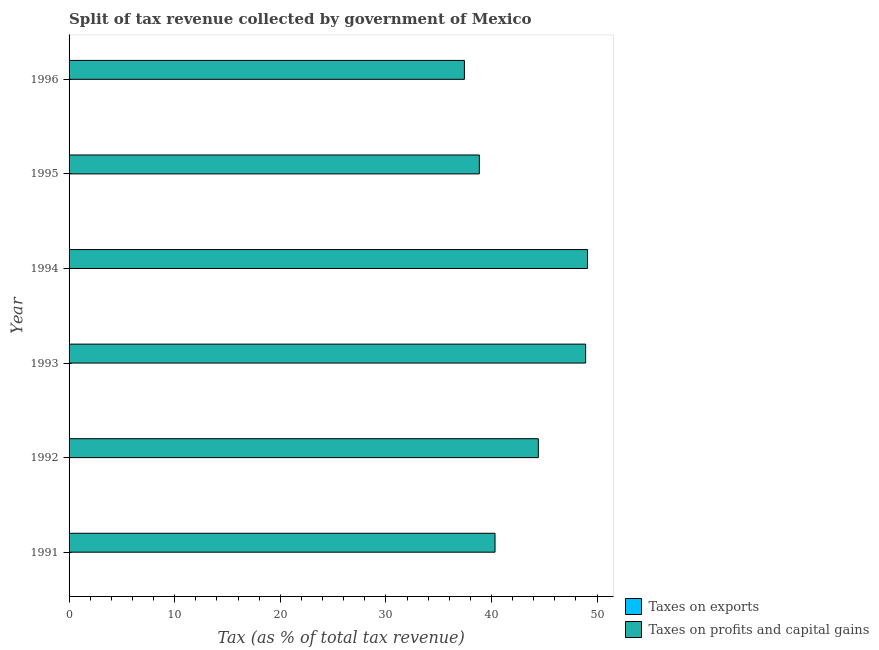Are the number of bars per tick equal to the number of legend labels?
Provide a short and direct response. Yes. In how many cases, is the number of bars for a given year not equal to the number of legend labels?
Give a very brief answer. 0. What is the percentage of revenue obtained from taxes on exports in 1993?
Your answer should be very brief. 0.02. Across all years, what is the maximum percentage of revenue obtained from taxes on exports?
Give a very brief answer. 0.04. Across all years, what is the minimum percentage of revenue obtained from taxes on exports?
Offer a very short reply. 0.02. In which year was the percentage of revenue obtained from taxes on profits and capital gains maximum?
Offer a very short reply. 1994. In which year was the percentage of revenue obtained from taxes on profits and capital gains minimum?
Your answer should be compact. 1996. What is the total percentage of revenue obtained from taxes on exports in the graph?
Ensure brevity in your answer.  0.17. What is the difference between the percentage of revenue obtained from taxes on exports in 1991 and that in 1993?
Your answer should be compact. 0.02. What is the difference between the percentage of revenue obtained from taxes on profits and capital gains in 1992 and the percentage of revenue obtained from taxes on exports in 1994?
Provide a succinct answer. 44.41. What is the average percentage of revenue obtained from taxes on exports per year?
Keep it short and to the point. 0.03. In the year 1991, what is the difference between the percentage of revenue obtained from taxes on exports and percentage of revenue obtained from taxes on profits and capital gains?
Make the answer very short. -40.3. In how many years, is the percentage of revenue obtained from taxes on profits and capital gains greater than 18 %?
Provide a succinct answer. 6. What is the ratio of the percentage of revenue obtained from taxes on exports in 1991 to that in 1994?
Your answer should be very brief. 1.42. Is the percentage of revenue obtained from taxes on profits and capital gains in 1992 less than that in 1994?
Give a very brief answer. Yes. Is the difference between the percentage of revenue obtained from taxes on exports in 1991 and 1992 greater than the difference between the percentage of revenue obtained from taxes on profits and capital gains in 1991 and 1992?
Make the answer very short. Yes. What is the difference between the highest and the second highest percentage of revenue obtained from taxes on exports?
Provide a short and direct response. 0.01. What is the difference between the highest and the lowest percentage of revenue obtained from taxes on exports?
Your answer should be very brief. 0.02. In how many years, is the percentage of revenue obtained from taxes on exports greater than the average percentage of revenue obtained from taxes on exports taken over all years?
Make the answer very short. 3. What does the 1st bar from the top in 1993 represents?
Provide a short and direct response. Taxes on profits and capital gains. What does the 2nd bar from the bottom in 1995 represents?
Your answer should be compact. Taxes on profits and capital gains. Are all the bars in the graph horizontal?
Provide a short and direct response. Yes. Does the graph contain any zero values?
Your answer should be compact. No. Where does the legend appear in the graph?
Keep it short and to the point. Bottom right. What is the title of the graph?
Provide a short and direct response. Split of tax revenue collected by government of Mexico. What is the label or title of the X-axis?
Provide a short and direct response. Tax (as % of total tax revenue). What is the label or title of the Y-axis?
Give a very brief answer. Year. What is the Tax (as % of total tax revenue) of Taxes on exports in 1991?
Keep it short and to the point. 0.04. What is the Tax (as % of total tax revenue) of Taxes on profits and capital gains in 1991?
Offer a very short reply. 40.34. What is the Tax (as % of total tax revenue) of Taxes on exports in 1992?
Offer a very short reply. 0.03. What is the Tax (as % of total tax revenue) of Taxes on profits and capital gains in 1992?
Your response must be concise. 44.43. What is the Tax (as % of total tax revenue) in Taxes on exports in 1993?
Make the answer very short. 0.02. What is the Tax (as % of total tax revenue) of Taxes on profits and capital gains in 1993?
Your answer should be very brief. 48.92. What is the Tax (as % of total tax revenue) in Taxes on exports in 1994?
Provide a short and direct response. 0.03. What is the Tax (as % of total tax revenue) in Taxes on profits and capital gains in 1994?
Ensure brevity in your answer.  49.1. What is the Tax (as % of total tax revenue) in Taxes on exports in 1995?
Provide a succinct answer. 0.03. What is the Tax (as % of total tax revenue) in Taxes on profits and capital gains in 1995?
Provide a short and direct response. 38.85. What is the Tax (as % of total tax revenue) of Taxes on exports in 1996?
Your answer should be compact. 0.02. What is the Tax (as % of total tax revenue) of Taxes on profits and capital gains in 1996?
Provide a succinct answer. 37.44. Across all years, what is the maximum Tax (as % of total tax revenue) of Taxes on exports?
Provide a succinct answer. 0.04. Across all years, what is the maximum Tax (as % of total tax revenue) in Taxes on profits and capital gains?
Provide a short and direct response. 49.1. Across all years, what is the minimum Tax (as % of total tax revenue) in Taxes on exports?
Offer a terse response. 0.02. Across all years, what is the minimum Tax (as % of total tax revenue) of Taxes on profits and capital gains?
Your answer should be compact. 37.44. What is the total Tax (as % of total tax revenue) of Taxes on exports in the graph?
Offer a terse response. 0.17. What is the total Tax (as % of total tax revenue) in Taxes on profits and capital gains in the graph?
Your answer should be compact. 259.07. What is the difference between the Tax (as % of total tax revenue) in Taxes on exports in 1991 and that in 1992?
Offer a very short reply. 0.01. What is the difference between the Tax (as % of total tax revenue) of Taxes on profits and capital gains in 1991 and that in 1992?
Offer a terse response. -4.1. What is the difference between the Tax (as % of total tax revenue) in Taxes on exports in 1991 and that in 1993?
Offer a very short reply. 0.02. What is the difference between the Tax (as % of total tax revenue) in Taxes on profits and capital gains in 1991 and that in 1993?
Ensure brevity in your answer.  -8.58. What is the difference between the Tax (as % of total tax revenue) of Taxes on exports in 1991 and that in 1994?
Your response must be concise. 0.01. What is the difference between the Tax (as % of total tax revenue) of Taxes on profits and capital gains in 1991 and that in 1994?
Provide a short and direct response. -8.76. What is the difference between the Tax (as % of total tax revenue) in Taxes on exports in 1991 and that in 1995?
Provide a succinct answer. 0.01. What is the difference between the Tax (as % of total tax revenue) of Taxes on profits and capital gains in 1991 and that in 1995?
Offer a very short reply. 1.49. What is the difference between the Tax (as % of total tax revenue) of Taxes on exports in 1991 and that in 1996?
Give a very brief answer. 0.02. What is the difference between the Tax (as % of total tax revenue) of Taxes on profits and capital gains in 1991 and that in 1996?
Offer a very short reply. 2.9. What is the difference between the Tax (as % of total tax revenue) in Taxes on exports in 1992 and that in 1993?
Make the answer very short. 0.01. What is the difference between the Tax (as % of total tax revenue) in Taxes on profits and capital gains in 1992 and that in 1993?
Offer a terse response. -4.48. What is the difference between the Tax (as % of total tax revenue) in Taxes on exports in 1992 and that in 1994?
Your response must be concise. 0. What is the difference between the Tax (as % of total tax revenue) in Taxes on profits and capital gains in 1992 and that in 1994?
Offer a terse response. -4.66. What is the difference between the Tax (as % of total tax revenue) of Taxes on exports in 1992 and that in 1995?
Make the answer very short. -0. What is the difference between the Tax (as % of total tax revenue) of Taxes on profits and capital gains in 1992 and that in 1995?
Provide a succinct answer. 5.58. What is the difference between the Tax (as % of total tax revenue) of Taxes on exports in 1992 and that in 1996?
Offer a terse response. 0.01. What is the difference between the Tax (as % of total tax revenue) in Taxes on profits and capital gains in 1992 and that in 1996?
Provide a succinct answer. 7. What is the difference between the Tax (as % of total tax revenue) in Taxes on exports in 1993 and that in 1994?
Make the answer very short. -0. What is the difference between the Tax (as % of total tax revenue) of Taxes on profits and capital gains in 1993 and that in 1994?
Your answer should be very brief. -0.18. What is the difference between the Tax (as % of total tax revenue) of Taxes on exports in 1993 and that in 1995?
Offer a terse response. -0.01. What is the difference between the Tax (as % of total tax revenue) in Taxes on profits and capital gains in 1993 and that in 1995?
Ensure brevity in your answer.  10.07. What is the difference between the Tax (as % of total tax revenue) in Taxes on exports in 1993 and that in 1996?
Offer a terse response. 0. What is the difference between the Tax (as % of total tax revenue) of Taxes on profits and capital gains in 1993 and that in 1996?
Keep it short and to the point. 11.48. What is the difference between the Tax (as % of total tax revenue) of Taxes on exports in 1994 and that in 1995?
Offer a terse response. -0.01. What is the difference between the Tax (as % of total tax revenue) of Taxes on profits and capital gains in 1994 and that in 1995?
Keep it short and to the point. 10.25. What is the difference between the Tax (as % of total tax revenue) of Taxes on exports in 1994 and that in 1996?
Your response must be concise. 0.01. What is the difference between the Tax (as % of total tax revenue) of Taxes on profits and capital gains in 1994 and that in 1996?
Your answer should be compact. 11.66. What is the difference between the Tax (as % of total tax revenue) of Taxes on exports in 1995 and that in 1996?
Give a very brief answer. 0.01. What is the difference between the Tax (as % of total tax revenue) of Taxes on profits and capital gains in 1995 and that in 1996?
Give a very brief answer. 1.42. What is the difference between the Tax (as % of total tax revenue) of Taxes on exports in 1991 and the Tax (as % of total tax revenue) of Taxes on profits and capital gains in 1992?
Provide a succinct answer. -44.4. What is the difference between the Tax (as % of total tax revenue) in Taxes on exports in 1991 and the Tax (as % of total tax revenue) in Taxes on profits and capital gains in 1993?
Ensure brevity in your answer.  -48.88. What is the difference between the Tax (as % of total tax revenue) in Taxes on exports in 1991 and the Tax (as % of total tax revenue) in Taxes on profits and capital gains in 1994?
Keep it short and to the point. -49.06. What is the difference between the Tax (as % of total tax revenue) in Taxes on exports in 1991 and the Tax (as % of total tax revenue) in Taxes on profits and capital gains in 1995?
Ensure brevity in your answer.  -38.81. What is the difference between the Tax (as % of total tax revenue) of Taxes on exports in 1991 and the Tax (as % of total tax revenue) of Taxes on profits and capital gains in 1996?
Your answer should be very brief. -37.4. What is the difference between the Tax (as % of total tax revenue) in Taxes on exports in 1992 and the Tax (as % of total tax revenue) in Taxes on profits and capital gains in 1993?
Offer a very short reply. -48.89. What is the difference between the Tax (as % of total tax revenue) in Taxes on exports in 1992 and the Tax (as % of total tax revenue) in Taxes on profits and capital gains in 1994?
Offer a very short reply. -49.07. What is the difference between the Tax (as % of total tax revenue) of Taxes on exports in 1992 and the Tax (as % of total tax revenue) of Taxes on profits and capital gains in 1995?
Your answer should be very brief. -38.82. What is the difference between the Tax (as % of total tax revenue) of Taxes on exports in 1992 and the Tax (as % of total tax revenue) of Taxes on profits and capital gains in 1996?
Offer a terse response. -37.41. What is the difference between the Tax (as % of total tax revenue) in Taxes on exports in 1993 and the Tax (as % of total tax revenue) in Taxes on profits and capital gains in 1994?
Your response must be concise. -49.08. What is the difference between the Tax (as % of total tax revenue) of Taxes on exports in 1993 and the Tax (as % of total tax revenue) of Taxes on profits and capital gains in 1995?
Provide a succinct answer. -38.83. What is the difference between the Tax (as % of total tax revenue) of Taxes on exports in 1993 and the Tax (as % of total tax revenue) of Taxes on profits and capital gains in 1996?
Keep it short and to the point. -37.41. What is the difference between the Tax (as % of total tax revenue) in Taxes on exports in 1994 and the Tax (as % of total tax revenue) in Taxes on profits and capital gains in 1995?
Offer a very short reply. -38.82. What is the difference between the Tax (as % of total tax revenue) of Taxes on exports in 1994 and the Tax (as % of total tax revenue) of Taxes on profits and capital gains in 1996?
Your answer should be very brief. -37.41. What is the difference between the Tax (as % of total tax revenue) of Taxes on exports in 1995 and the Tax (as % of total tax revenue) of Taxes on profits and capital gains in 1996?
Give a very brief answer. -37.4. What is the average Tax (as % of total tax revenue) of Taxes on exports per year?
Offer a terse response. 0.03. What is the average Tax (as % of total tax revenue) in Taxes on profits and capital gains per year?
Provide a succinct answer. 43.18. In the year 1991, what is the difference between the Tax (as % of total tax revenue) of Taxes on exports and Tax (as % of total tax revenue) of Taxes on profits and capital gains?
Offer a very short reply. -40.3. In the year 1992, what is the difference between the Tax (as % of total tax revenue) in Taxes on exports and Tax (as % of total tax revenue) in Taxes on profits and capital gains?
Your answer should be compact. -44.41. In the year 1993, what is the difference between the Tax (as % of total tax revenue) of Taxes on exports and Tax (as % of total tax revenue) of Taxes on profits and capital gains?
Keep it short and to the point. -48.89. In the year 1994, what is the difference between the Tax (as % of total tax revenue) in Taxes on exports and Tax (as % of total tax revenue) in Taxes on profits and capital gains?
Offer a terse response. -49.07. In the year 1995, what is the difference between the Tax (as % of total tax revenue) of Taxes on exports and Tax (as % of total tax revenue) of Taxes on profits and capital gains?
Offer a very short reply. -38.82. In the year 1996, what is the difference between the Tax (as % of total tax revenue) in Taxes on exports and Tax (as % of total tax revenue) in Taxes on profits and capital gains?
Give a very brief answer. -37.42. What is the ratio of the Tax (as % of total tax revenue) in Taxes on exports in 1991 to that in 1992?
Your answer should be very brief. 1.28. What is the ratio of the Tax (as % of total tax revenue) of Taxes on profits and capital gains in 1991 to that in 1992?
Your answer should be very brief. 0.91. What is the ratio of the Tax (as % of total tax revenue) in Taxes on exports in 1991 to that in 1993?
Offer a very short reply. 1.71. What is the ratio of the Tax (as % of total tax revenue) in Taxes on profits and capital gains in 1991 to that in 1993?
Offer a very short reply. 0.82. What is the ratio of the Tax (as % of total tax revenue) of Taxes on exports in 1991 to that in 1994?
Your answer should be compact. 1.41. What is the ratio of the Tax (as % of total tax revenue) in Taxes on profits and capital gains in 1991 to that in 1994?
Ensure brevity in your answer.  0.82. What is the ratio of the Tax (as % of total tax revenue) in Taxes on exports in 1991 to that in 1995?
Ensure brevity in your answer.  1.16. What is the ratio of the Tax (as % of total tax revenue) of Taxes on profits and capital gains in 1991 to that in 1995?
Ensure brevity in your answer.  1.04. What is the ratio of the Tax (as % of total tax revenue) in Taxes on exports in 1991 to that in 1996?
Give a very brief answer. 2.04. What is the ratio of the Tax (as % of total tax revenue) in Taxes on profits and capital gains in 1991 to that in 1996?
Your answer should be compact. 1.08. What is the ratio of the Tax (as % of total tax revenue) in Taxes on exports in 1992 to that in 1993?
Ensure brevity in your answer.  1.33. What is the ratio of the Tax (as % of total tax revenue) of Taxes on profits and capital gains in 1992 to that in 1993?
Provide a short and direct response. 0.91. What is the ratio of the Tax (as % of total tax revenue) of Taxes on exports in 1992 to that in 1994?
Your answer should be compact. 1.1. What is the ratio of the Tax (as % of total tax revenue) of Taxes on profits and capital gains in 1992 to that in 1994?
Provide a short and direct response. 0.91. What is the ratio of the Tax (as % of total tax revenue) in Taxes on exports in 1992 to that in 1995?
Your response must be concise. 0.91. What is the ratio of the Tax (as % of total tax revenue) in Taxes on profits and capital gains in 1992 to that in 1995?
Your answer should be very brief. 1.14. What is the ratio of the Tax (as % of total tax revenue) of Taxes on exports in 1992 to that in 1996?
Offer a terse response. 1.59. What is the ratio of the Tax (as % of total tax revenue) in Taxes on profits and capital gains in 1992 to that in 1996?
Keep it short and to the point. 1.19. What is the ratio of the Tax (as % of total tax revenue) of Taxes on exports in 1993 to that in 1994?
Your answer should be compact. 0.83. What is the ratio of the Tax (as % of total tax revenue) of Taxes on exports in 1993 to that in 1995?
Keep it short and to the point. 0.68. What is the ratio of the Tax (as % of total tax revenue) of Taxes on profits and capital gains in 1993 to that in 1995?
Provide a succinct answer. 1.26. What is the ratio of the Tax (as % of total tax revenue) in Taxes on exports in 1993 to that in 1996?
Offer a terse response. 1.2. What is the ratio of the Tax (as % of total tax revenue) of Taxes on profits and capital gains in 1993 to that in 1996?
Provide a short and direct response. 1.31. What is the ratio of the Tax (as % of total tax revenue) in Taxes on exports in 1994 to that in 1995?
Your answer should be very brief. 0.82. What is the ratio of the Tax (as % of total tax revenue) in Taxes on profits and capital gains in 1994 to that in 1995?
Keep it short and to the point. 1.26. What is the ratio of the Tax (as % of total tax revenue) of Taxes on exports in 1994 to that in 1996?
Ensure brevity in your answer.  1.44. What is the ratio of the Tax (as % of total tax revenue) in Taxes on profits and capital gains in 1994 to that in 1996?
Offer a very short reply. 1.31. What is the ratio of the Tax (as % of total tax revenue) in Taxes on exports in 1995 to that in 1996?
Offer a very short reply. 1.76. What is the ratio of the Tax (as % of total tax revenue) in Taxes on profits and capital gains in 1995 to that in 1996?
Your answer should be very brief. 1.04. What is the difference between the highest and the second highest Tax (as % of total tax revenue) of Taxes on exports?
Ensure brevity in your answer.  0.01. What is the difference between the highest and the second highest Tax (as % of total tax revenue) of Taxes on profits and capital gains?
Your answer should be compact. 0.18. What is the difference between the highest and the lowest Tax (as % of total tax revenue) of Taxes on exports?
Make the answer very short. 0.02. What is the difference between the highest and the lowest Tax (as % of total tax revenue) in Taxes on profits and capital gains?
Provide a succinct answer. 11.66. 